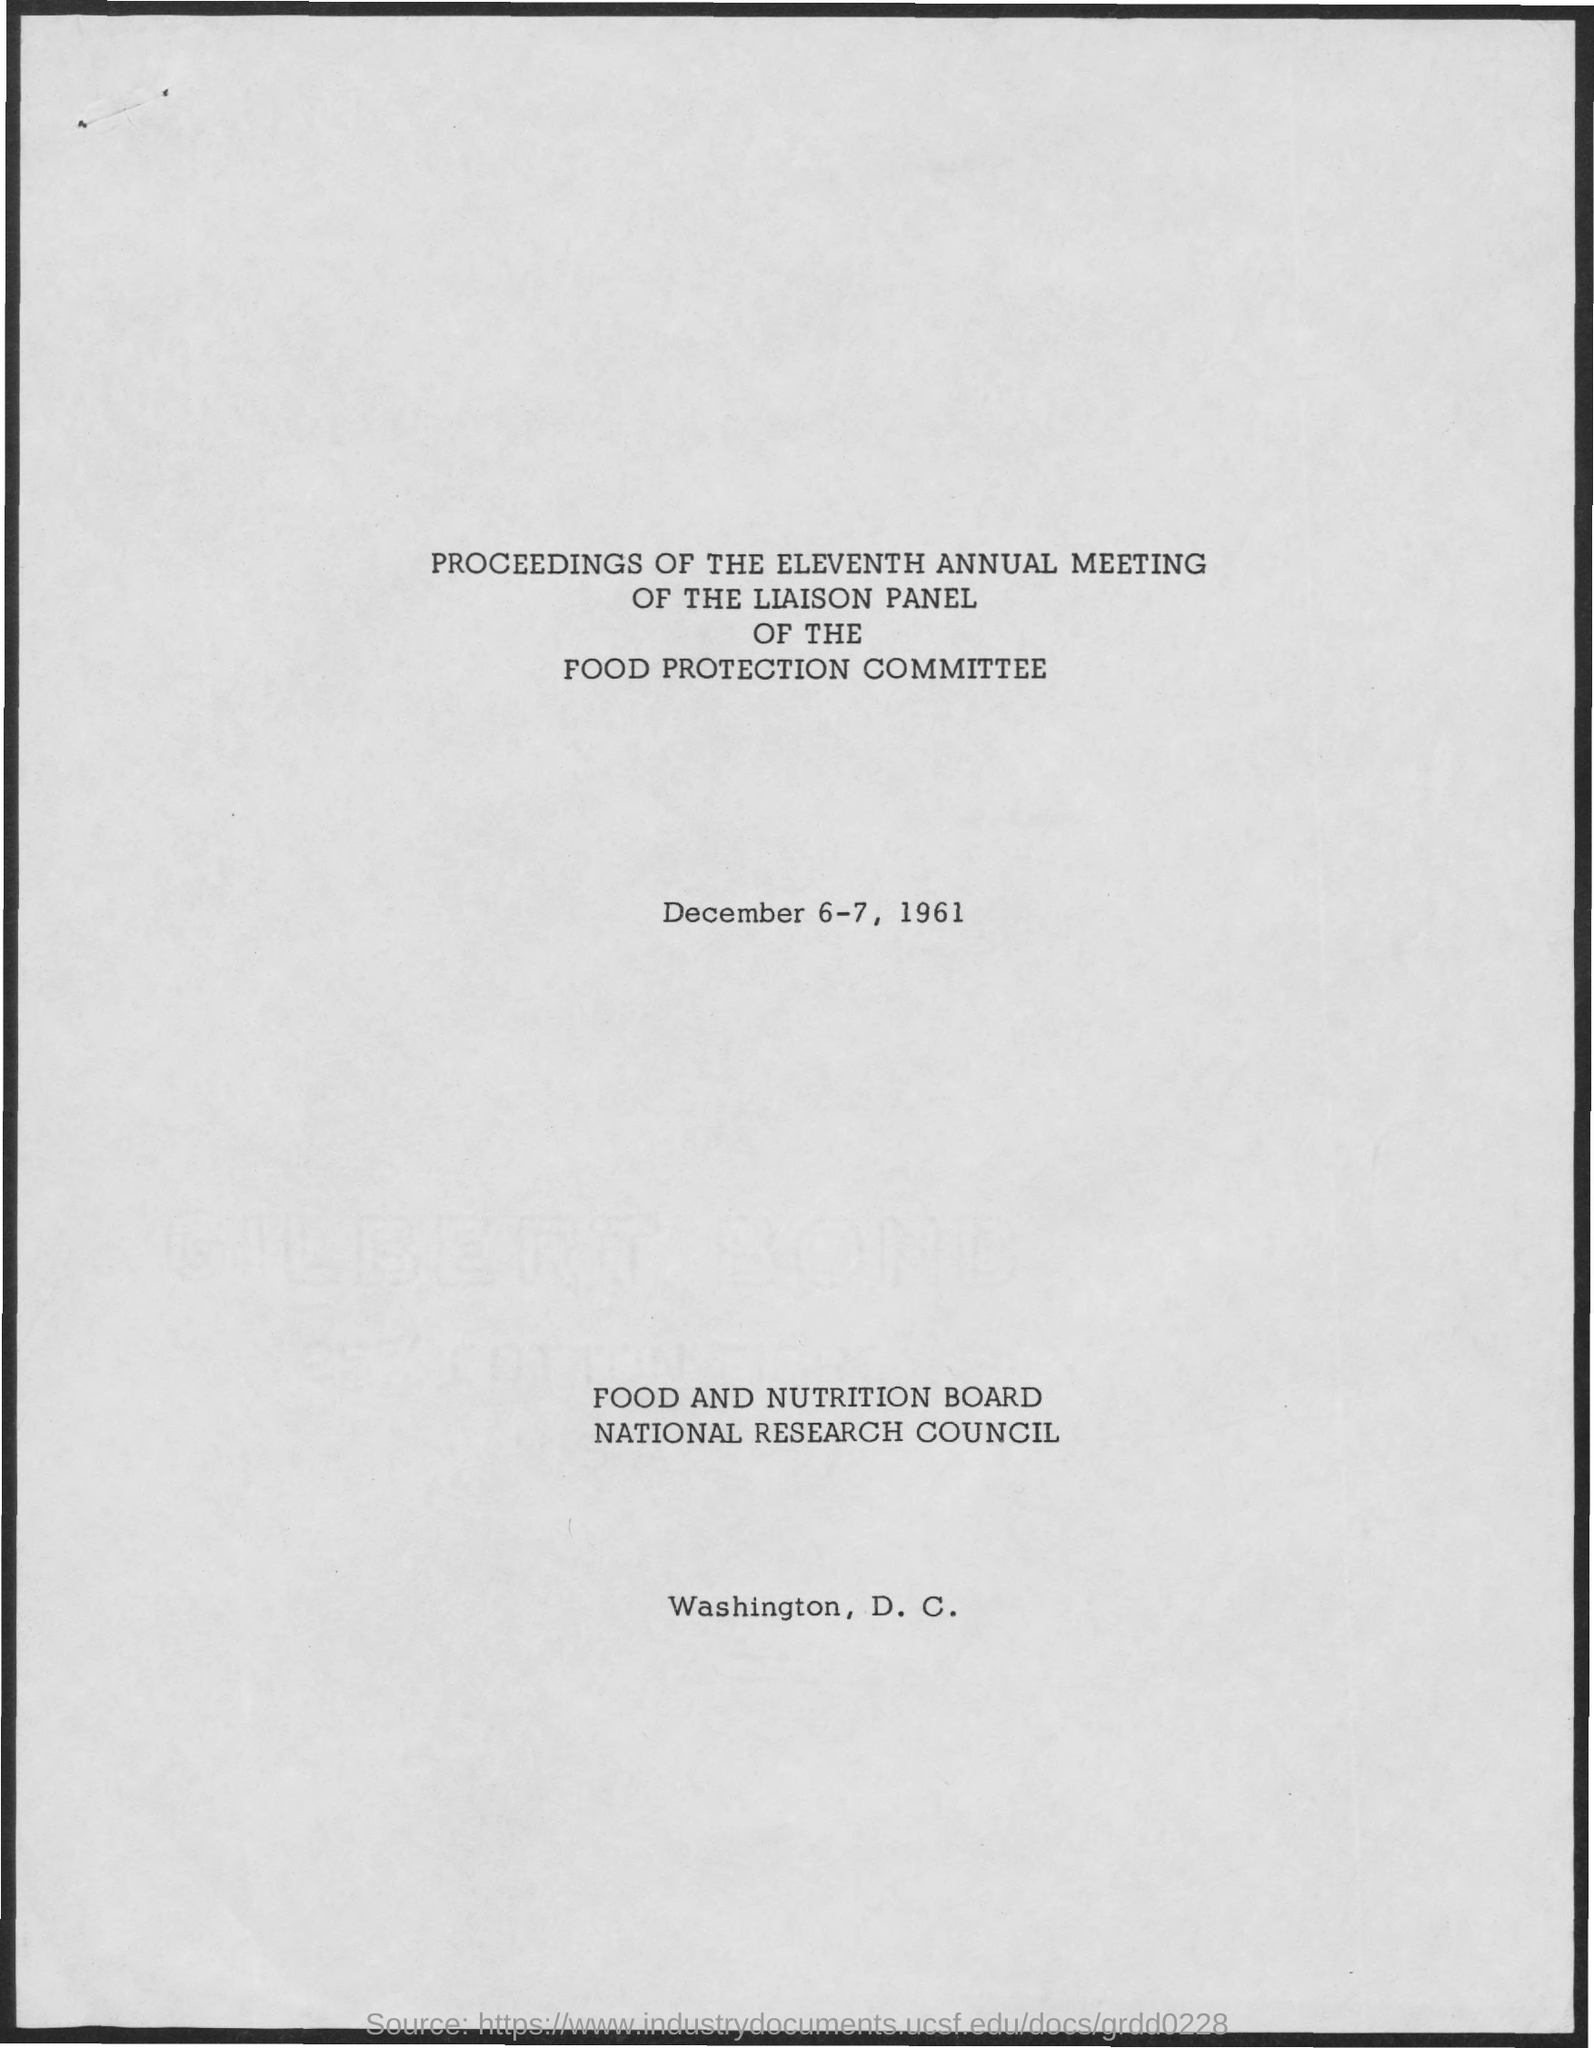Draw attention to some important aspects in this diagram. The meeting will take place on December 6-7, 1961. The location of the Food and Nutrition Board of the National Research Council is in Washington, D.C. 